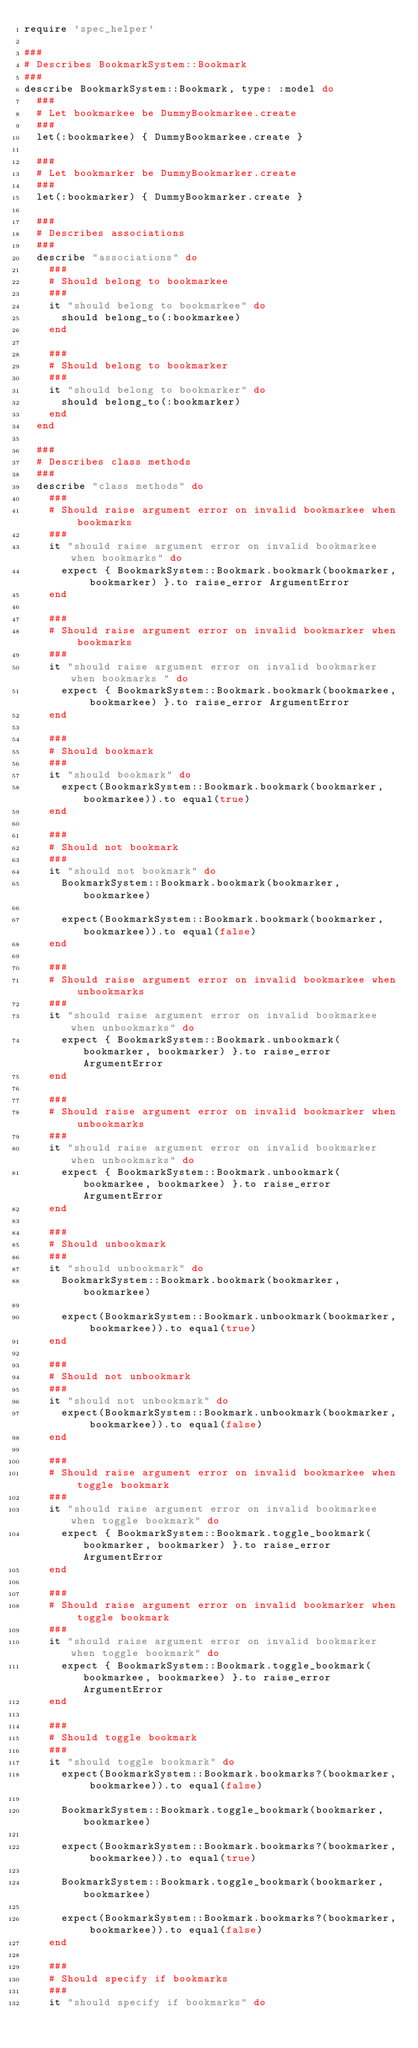<code> <loc_0><loc_0><loc_500><loc_500><_Ruby_>require 'spec_helper'

###
# Describes BookmarkSystem::Bookmark
###
describe BookmarkSystem::Bookmark, type: :model do
  ###
  # Let bookmarkee be DummyBookmarkee.create
  ###
  let(:bookmarkee) { DummyBookmarkee.create }

  ###
  # Let bookmarker be DummyBookmarker.create
  ###
  let(:bookmarker) { DummyBookmarker.create }

  ###
  # Describes associations
  ###
  describe "associations" do
    ###
    # Should belong to bookmarkee
    ###
    it "should belong to bookmarkee" do
      should belong_to(:bookmarkee)
    end

    ###
    # Should belong to bookmarker
    ###
    it "should belong to bookmarker" do
      should belong_to(:bookmarker)
    end
  end

  ###
  # Describes class methods
  ###
  describe "class methods" do
    ###
    # Should raise argument error on invalid bookmarkee when bookmarks
    ###
    it "should raise argument error on invalid bookmarkee when bookmarks" do
      expect { BookmarkSystem::Bookmark.bookmark(bookmarker, bookmarker) }.to raise_error ArgumentError
    end

    ###
    # Should raise argument error on invalid bookmarker when bookmarks
    ###
    it "should raise argument error on invalid bookmarker when bookmarks " do
      expect { BookmarkSystem::Bookmark.bookmark(bookmarkee, bookmarkee) }.to raise_error ArgumentError
    end

    ###
    # Should bookmark
    ###
    it "should bookmark" do
      expect(BookmarkSystem::Bookmark.bookmark(bookmarker, bookmarkee)).to equal(true)
    end

    ###
    # Should not bookmark
    ###
    it "should not bookmark" do
      BookmarkSystem::Bookmark.bookmark(bookmarker, bookmarkee)

      expect(BookmarkSystem::Bookmark.bookmark(bookmarker, bookmarkee)).to equal(false)
    end

    ###
    # Should raise argument error on invalid bookmarkee when unbookmarks
    ###
    it "should raise argument error on invalid bookmarkee when unbookmarks" do
      expect { BookmarkSystem::Bookmark.unbookmark(bookmarker, bookmarker) }.to raise_error ArgumentError
    end

    ###
    # Should raise argument error on invalid bookmarker when unbookmarks
    ###
    it "should raise argument error on invalid bookmarker when unbookmarks" do
      expect { BookmarkSystem::Bookmark.unbookmark(bookmarkee, bookmarkee) }.to raise_error ArgumentError
    end

    ###
    # Should unbookmark
    ###
    it "should unbookmark" do
      BookmarkSystem::Bookmark.bookmark(bookmarker, bookmarkee)

      expect(BookmarkSystem::Bookmark.unbookmark(bookmarker, bookmarkee)).to equal(true)
    end

    ###
    # Should not unbookmark
    ###
    it "should not unbookmark" do
      expect(BookmarkSystem::Bookmark.unbookmark(bookmarker, bookmarkee)).to equal(false)
    end

    ###
    # Should raise argument error on invalid bookmarkee when toggle bookmark
    ###
    it "should raise argument error on invalid bookmarkee when toggle bookmark" do
      expect { BookmarkSystem::Bookmark.toggle_bookmark(bookmarker, bookmarker) }.to raise_error ArgumentError
    end

    ###
    # Should raise argument error on invalid bookmarker when toggle bookmark
    ###
    it "should raise argument error on invalid bookmarker when toggle bookmark" do
      expect { BookmarkSystem::Bookmark.toggle_bookmark(bookmarkee, bookmarkee) }.to raise_error ArgumentError
    end

    ###
    # Should toggle bookmark
    ###
    it "should toggle bookmark" do
      expect(BookmarkSystem::Bookmark.bookmarks?(bookmarker, bookmarkee)).to equal(false)

      BookmarkSystem::Bookmark.toggle_bookmark(bookmarker, bookmarkee)

      expect(BookmarkSystem::Bookmark.bookmarks?(bookmarker, bookmarkee)).to equal(true)

      BookmarkSystem::Bookmark.toggle_bookmark(bookmarker, bookmarkee)

      expect(BookmarkSystem::Bookmark.bookmarks?(bookmarker, bookmarkee)).to equal(false)
    end

    ###
    # Should specify if bookmarks
    ###
    it "should specify if bookmarks" do</code> 